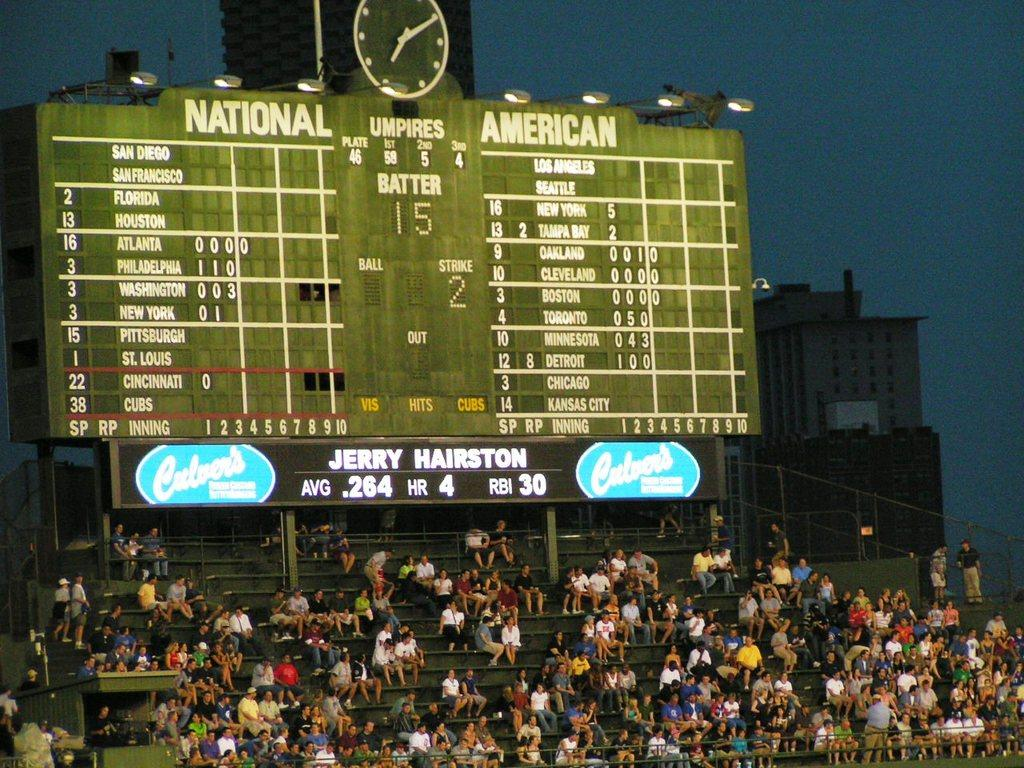<image>
Describe the image concisely. Score board with culvers and jerry hairston at bottom 